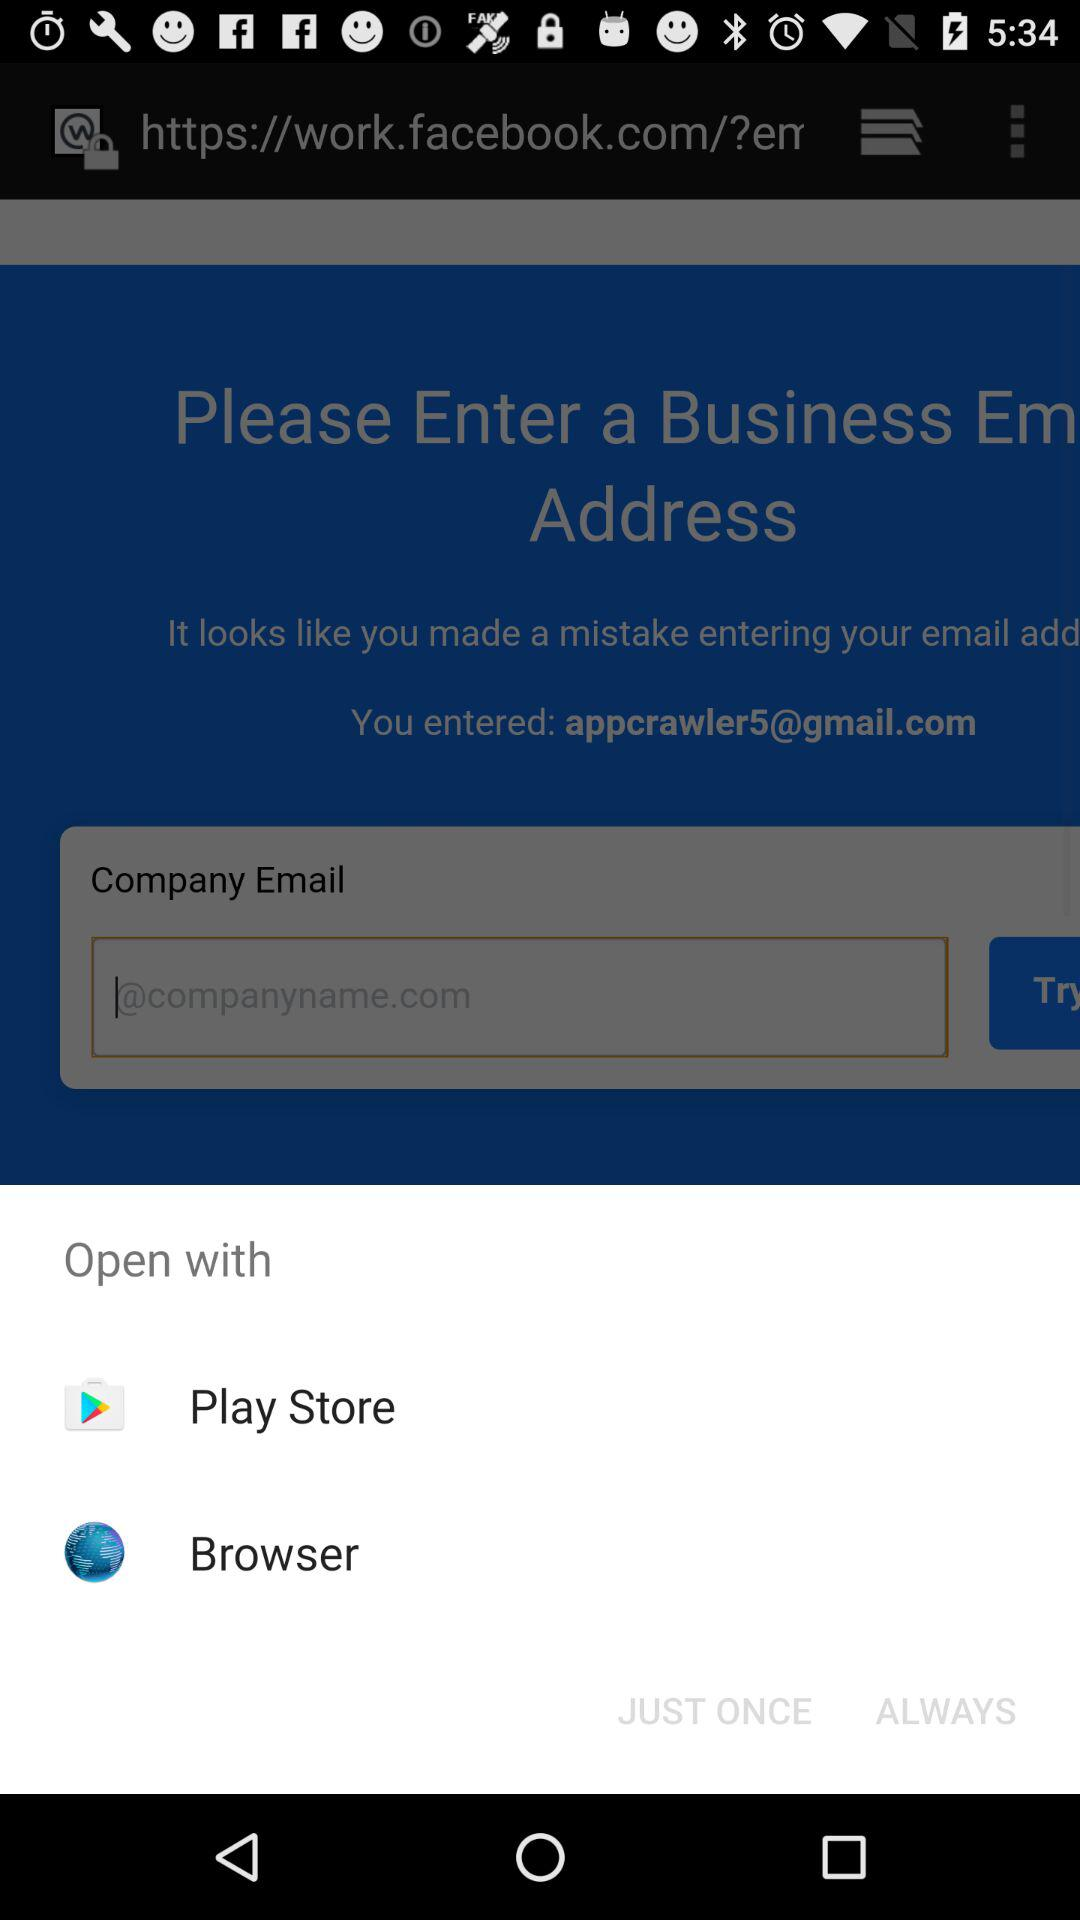Which applications can I open it with? You can open it with "Play Store" and "Browser". 